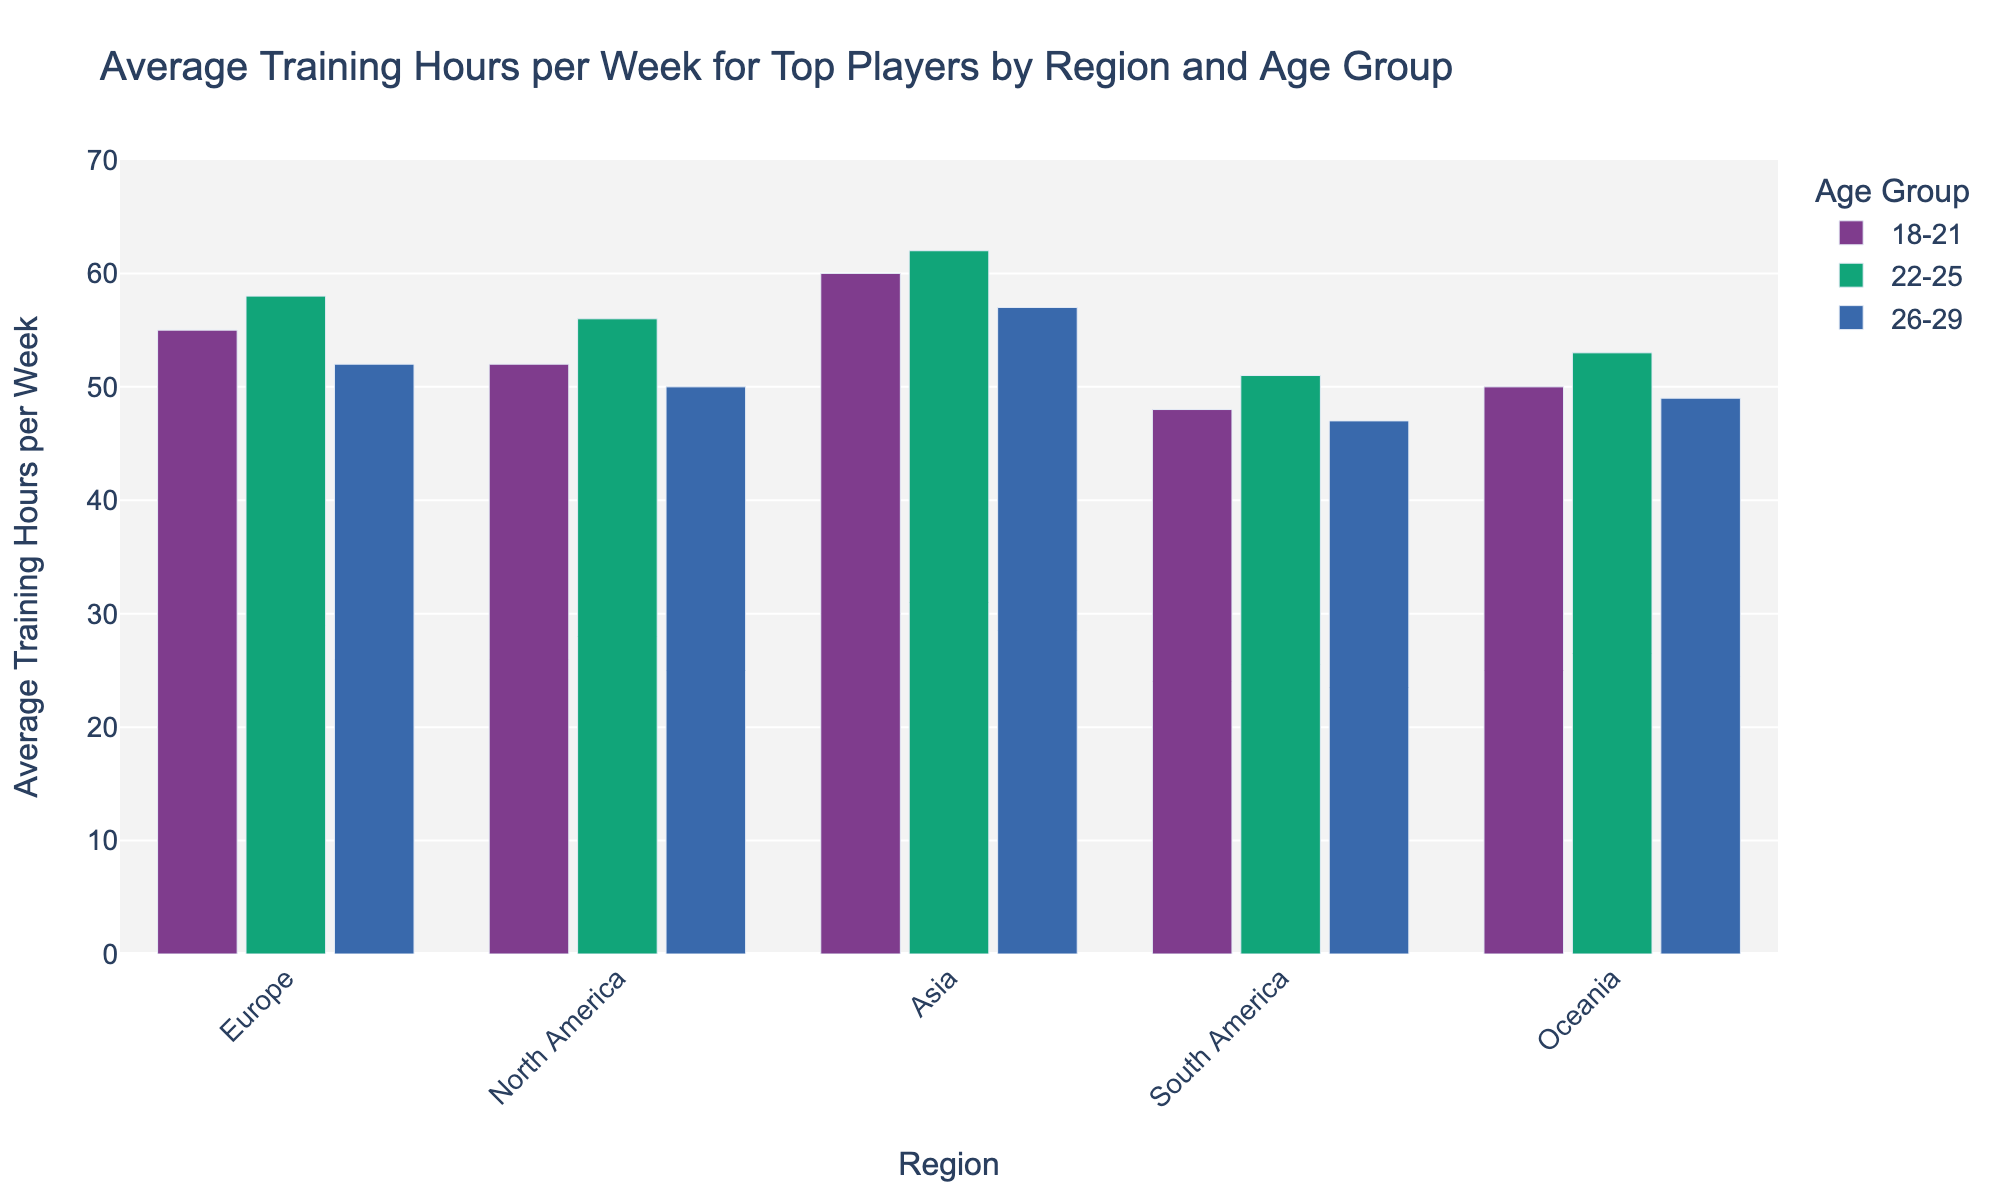Which region has the highest average training hours for the 18-21 age group? Look at the bars corresponding to the 18-21 age group across different regions and compare their heights. Asia has the highest bar for the 18-21 age group.
Answer: Asia What is the difference in average training hours between the 22-25 and 26-29 age groups in Oceania? Find the bars for Oceania corresponding to the 22-25 and 26-29 age groups. The average training hours are 53 and 49, respectively. Subtract 49 from 53.
Answer: 4 Which age group in Europe trains the most per week on average? Look at the bars under Europe, and identify the one with the maximum height. The 22-25 age group has the highest bar.
Answer: 22-25 What is the sum of the average training hours for the 18-21 age group in North America and South America? Find the bars corresponding to the 18-21 age group in North America and South America. Their heights are 52 and 48, respectively. Sum them up: 52 + 48.
Answer: 100 Which region has the lowest average training hours for the 22-25 age group? Compare the bars for the 22-25 age group across all regions. South America has the lowest bar.
Answer: South America How many more hours do players aged 26-29 in Asia train compared to those in Europe? Find the bars for the 26-29 age group in Asia and Europe. Their average training hours are 57 and 52, respectively. Subtract 52 from 57.
Answer: 5 Which age group in South America trains the least on average? Look at the bars under South America and identify the one with the minimum height. The 26-29 age group has the lowest bar.
Answer: 26-29 What is the average training hours for the 18-21 age group in Asia? Find the bar for the 18-21 age group in Asia and read off its height.
Answer: 60 